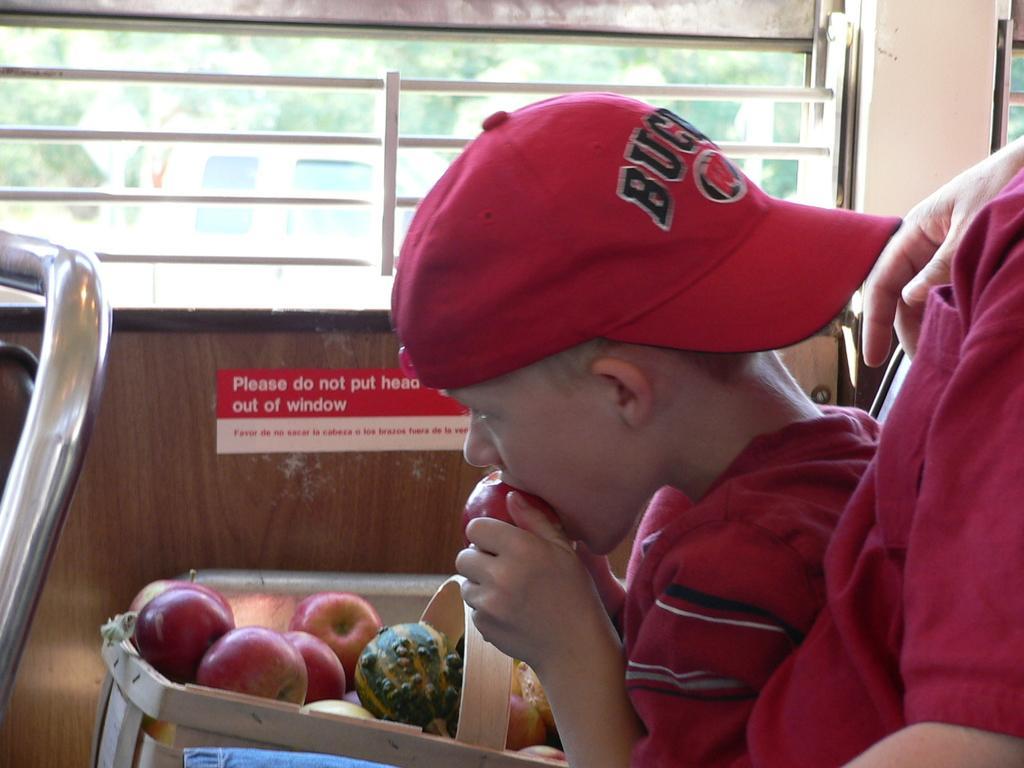Describe this image in one or two sentences. There is one kid sitting and wearing a red color jacket and a cap, and eating a fruit at the bottom of this image, and there is one other person on the right side of this image. There are some fruits kept in a basket at the bottom of this image. We can see there is a window at the top of this image, and there is an iron rod of a chair on the left side of this image. 